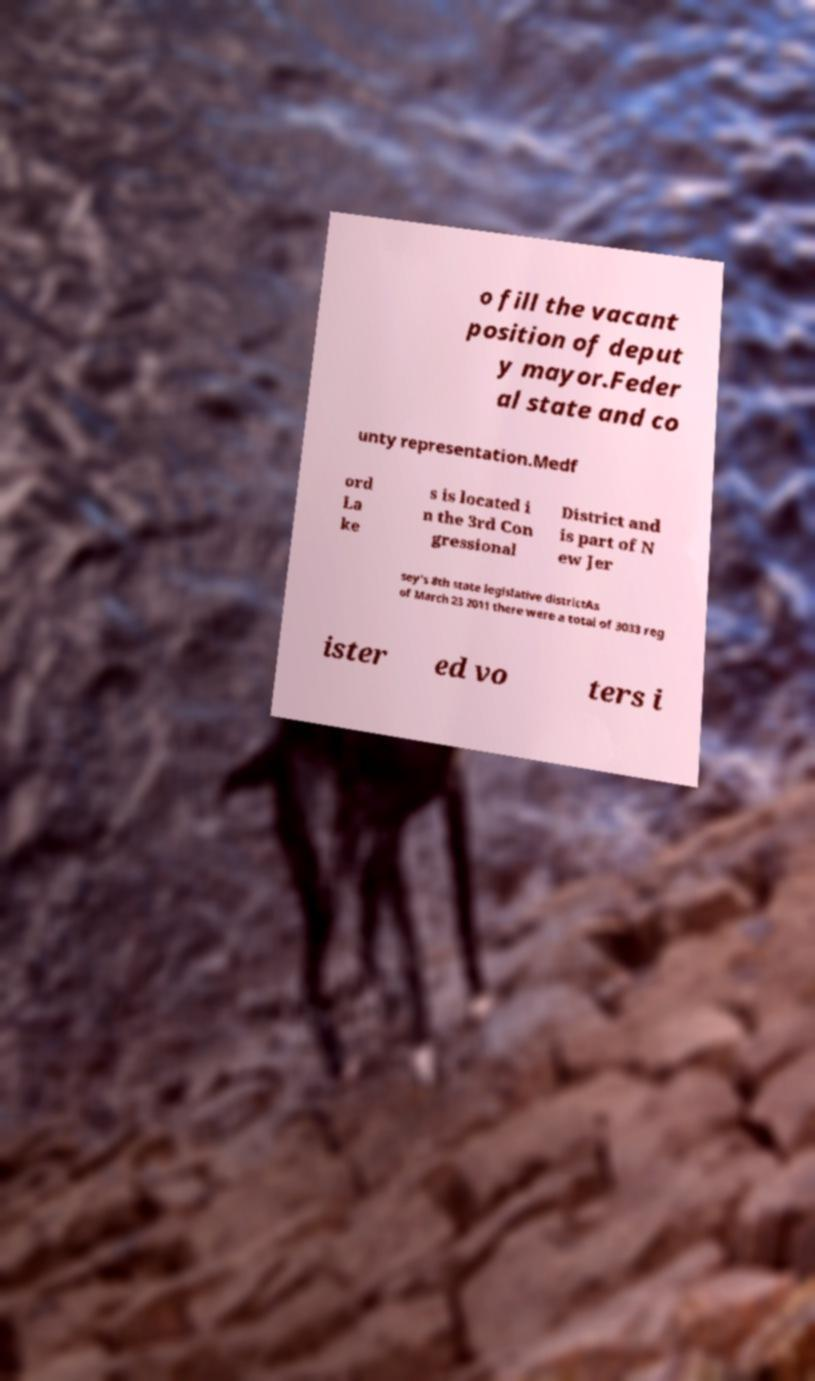Please read and relay the text visible in this image. What does it say? o fill the vacant position of deput y mayor.Feder al state and co unty representation.Medf ord La ke s is located i n the 3rd Con gressional District and is part of N ew Jer sey's 8th state legislative districtAs of March 23 2011 there were a total of 3033 reg ister ed vo ters i 